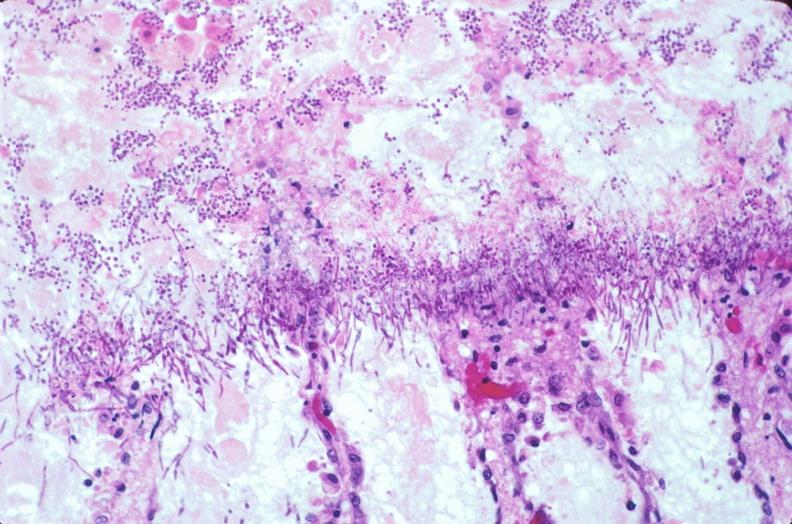what does this image show?
Answer the question using a single word or phrase. Duodenum 